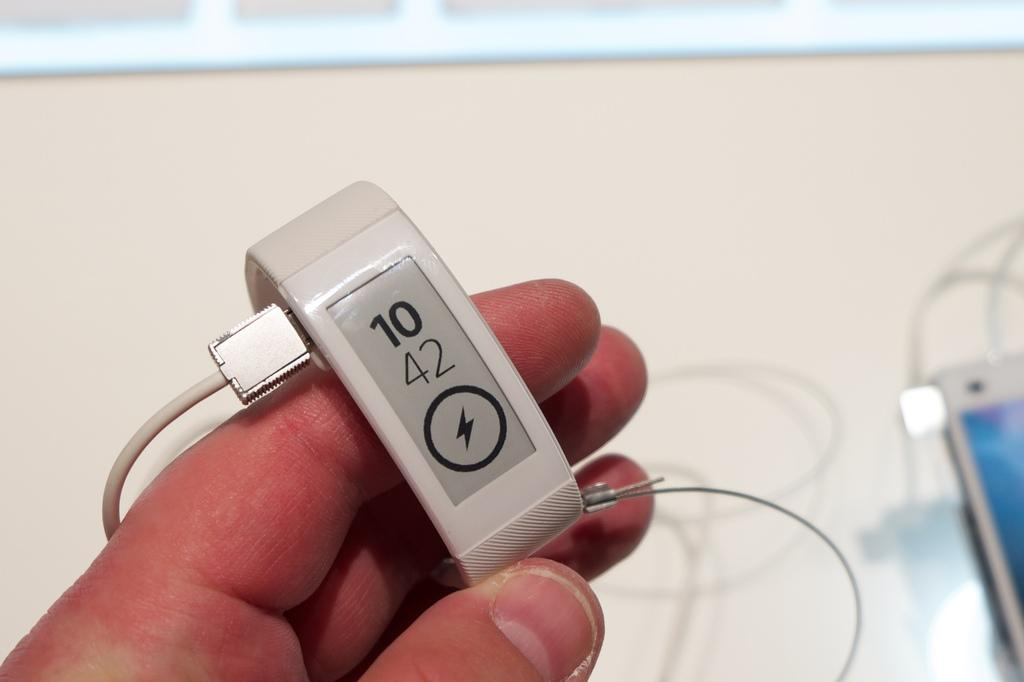<image>
Write a terse but informative summary of the picture. A smart watch with the numbers 10 42 and a charging symbol on its display. 